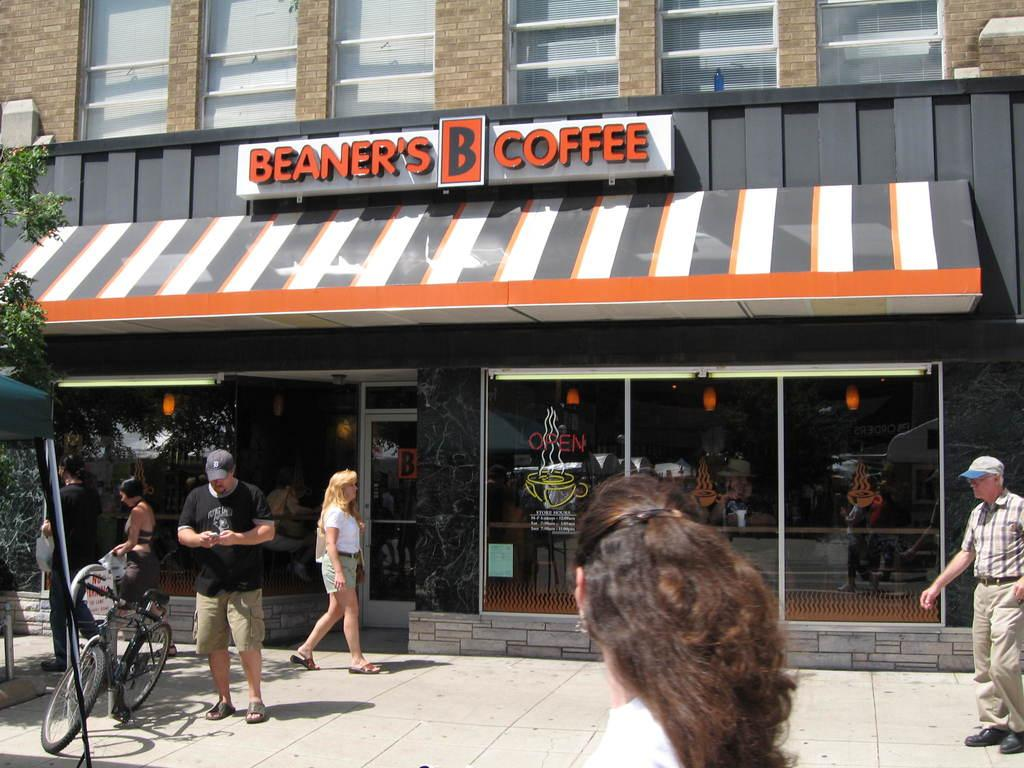Provide a one-sentence caption for the provided image. The front of Beaner's Coffee store with people walking by. 